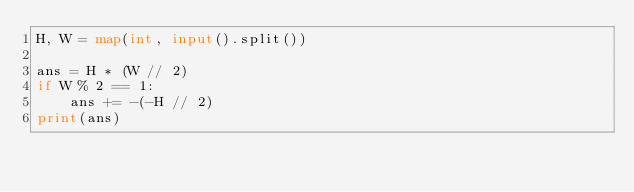Convert code to text. <code><loc_0><loc_0><loc_500><loc_500><_Python_>H, W = map(int, input().split())

ans = H * (W // 2)
if W % 2 == 1:
    ans += -(-H // 2)
print(ans)</code> 